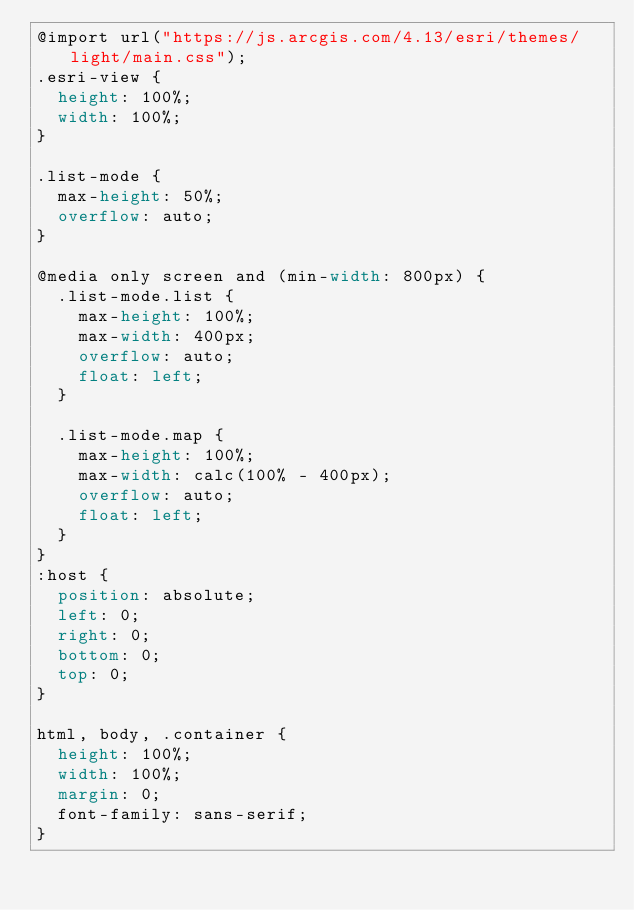Convert code to text. <code><loc_0><loc_0><loc_500><loc_500><_CSS_>@import url("https://js.arcgis.com/4.13/esri/themes/light/main.css");
.esri-view {
  height: 100%;
  width: 100%;
}

.list-mode {
  max-height: 50%;
  overflow: auto;
}

@media only screen and (min-width: 800px) {
  .list-mode.list {
    max-height: 100%;
    max-width: 400px;
    overflow: auto;
    float: left;
  }

  .list-mode.map {
    max-height: 100%;
    max-width: calc(100% - 400px);
    overflow: auto;
    float: left;
  }
}
:host {
  position: absolute;
  left: 0;
  right: 0;
  bottom: 0;
  top: 0;
}

html, body, .container {
  height: 100%;
  width: 100%;
  margin: 0;
  font-family: sans-serif;
}</code> 